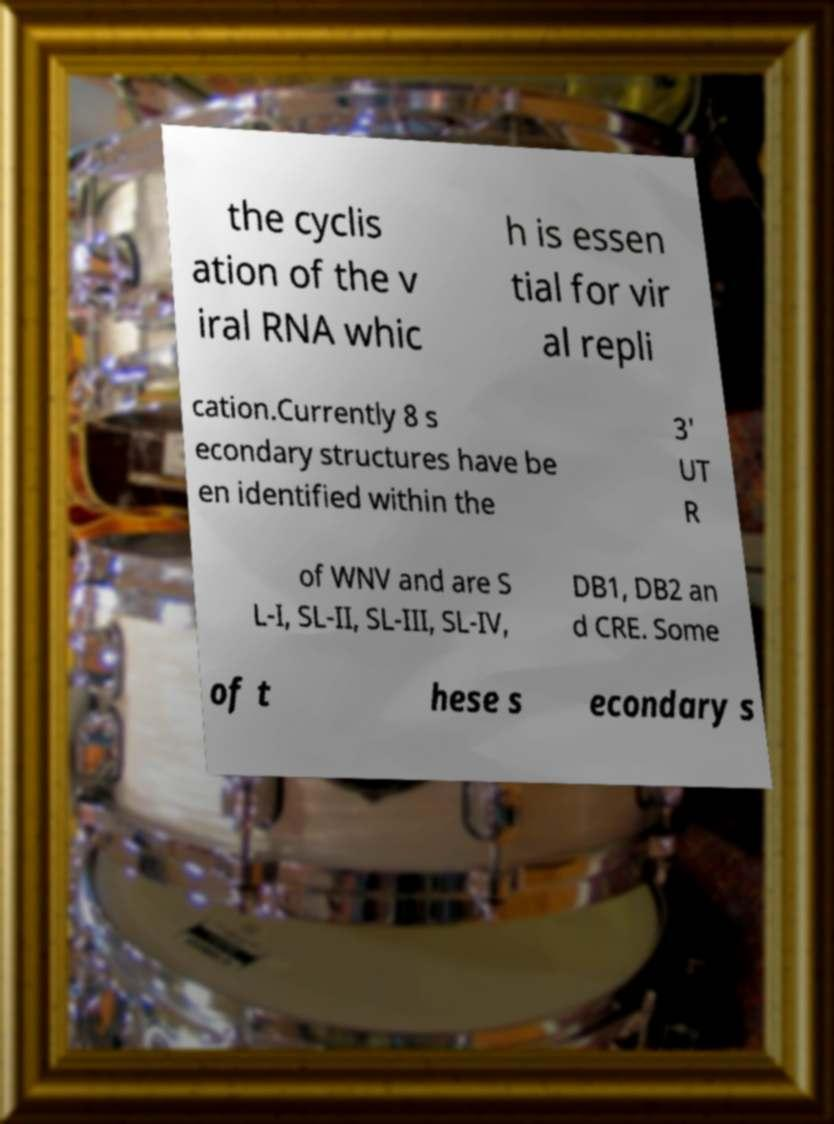Could you assist in decoding the text presented in this image and type it out clearly? the cyclis ation of the v iral RNA whic h is essen tial for vir al repli cation.Currently 8 s econdary structures have be en identified within the 3' UT R of WNV and are S L-I, SL-II, SL-III, SL-IV, DB1, DB2 an d CRE. Some of t hese s econdary s 